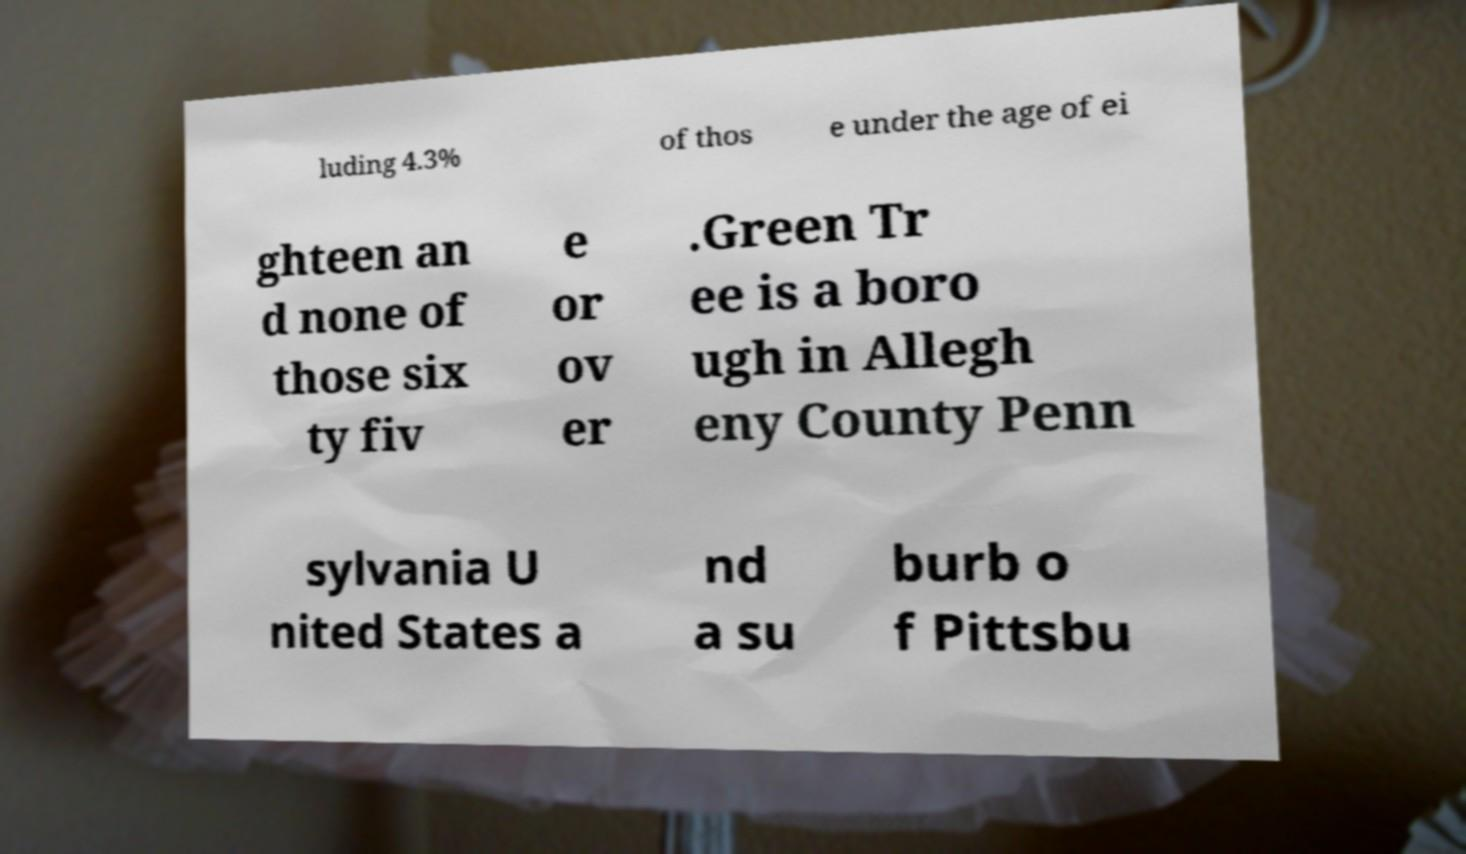Could you extract and type out the text from this image? luding 4.3% of thos e under the age of ei ghteen an d none of those six ty fiv e or ov er .Green Tr ee is a boro ugh in Allegh eny County Penn sylvania U nited States a nd a su burb o f Pittsbu 